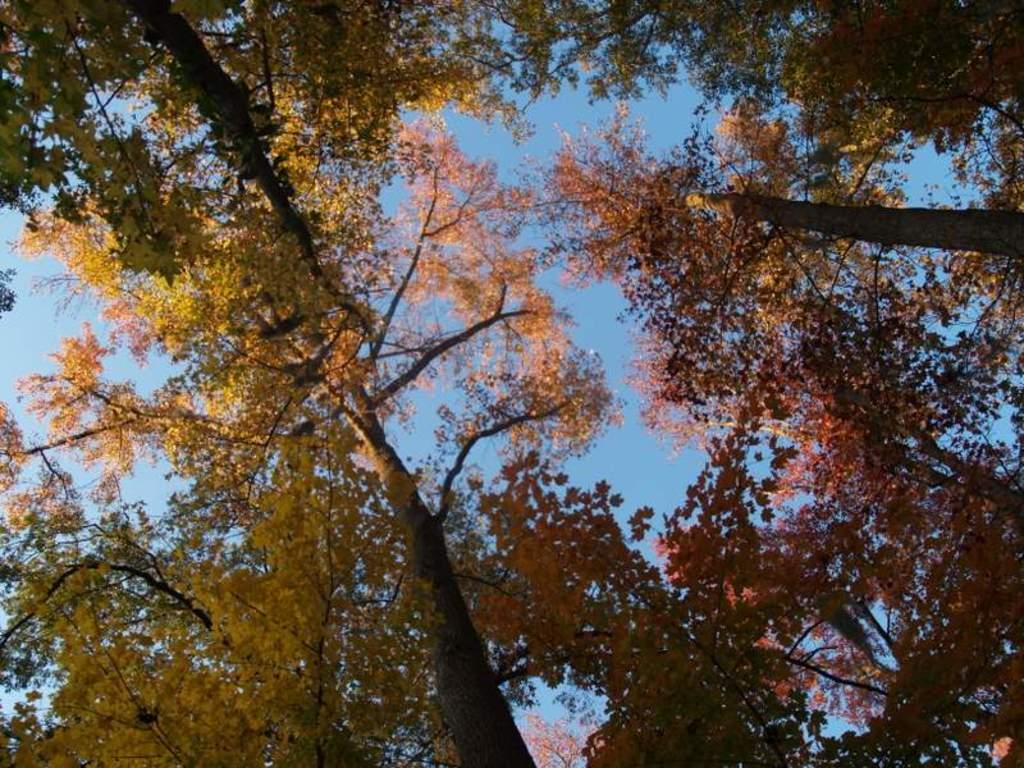What type of vegetation can be seen in the image? There are trees in the image. What part of the natural environment is visible in the image? The sky is visible in the background of the image. Can you hear the snail making any sounds in the image? There is no snail present in the image, so it is not possible to hear any sounds it might make. 